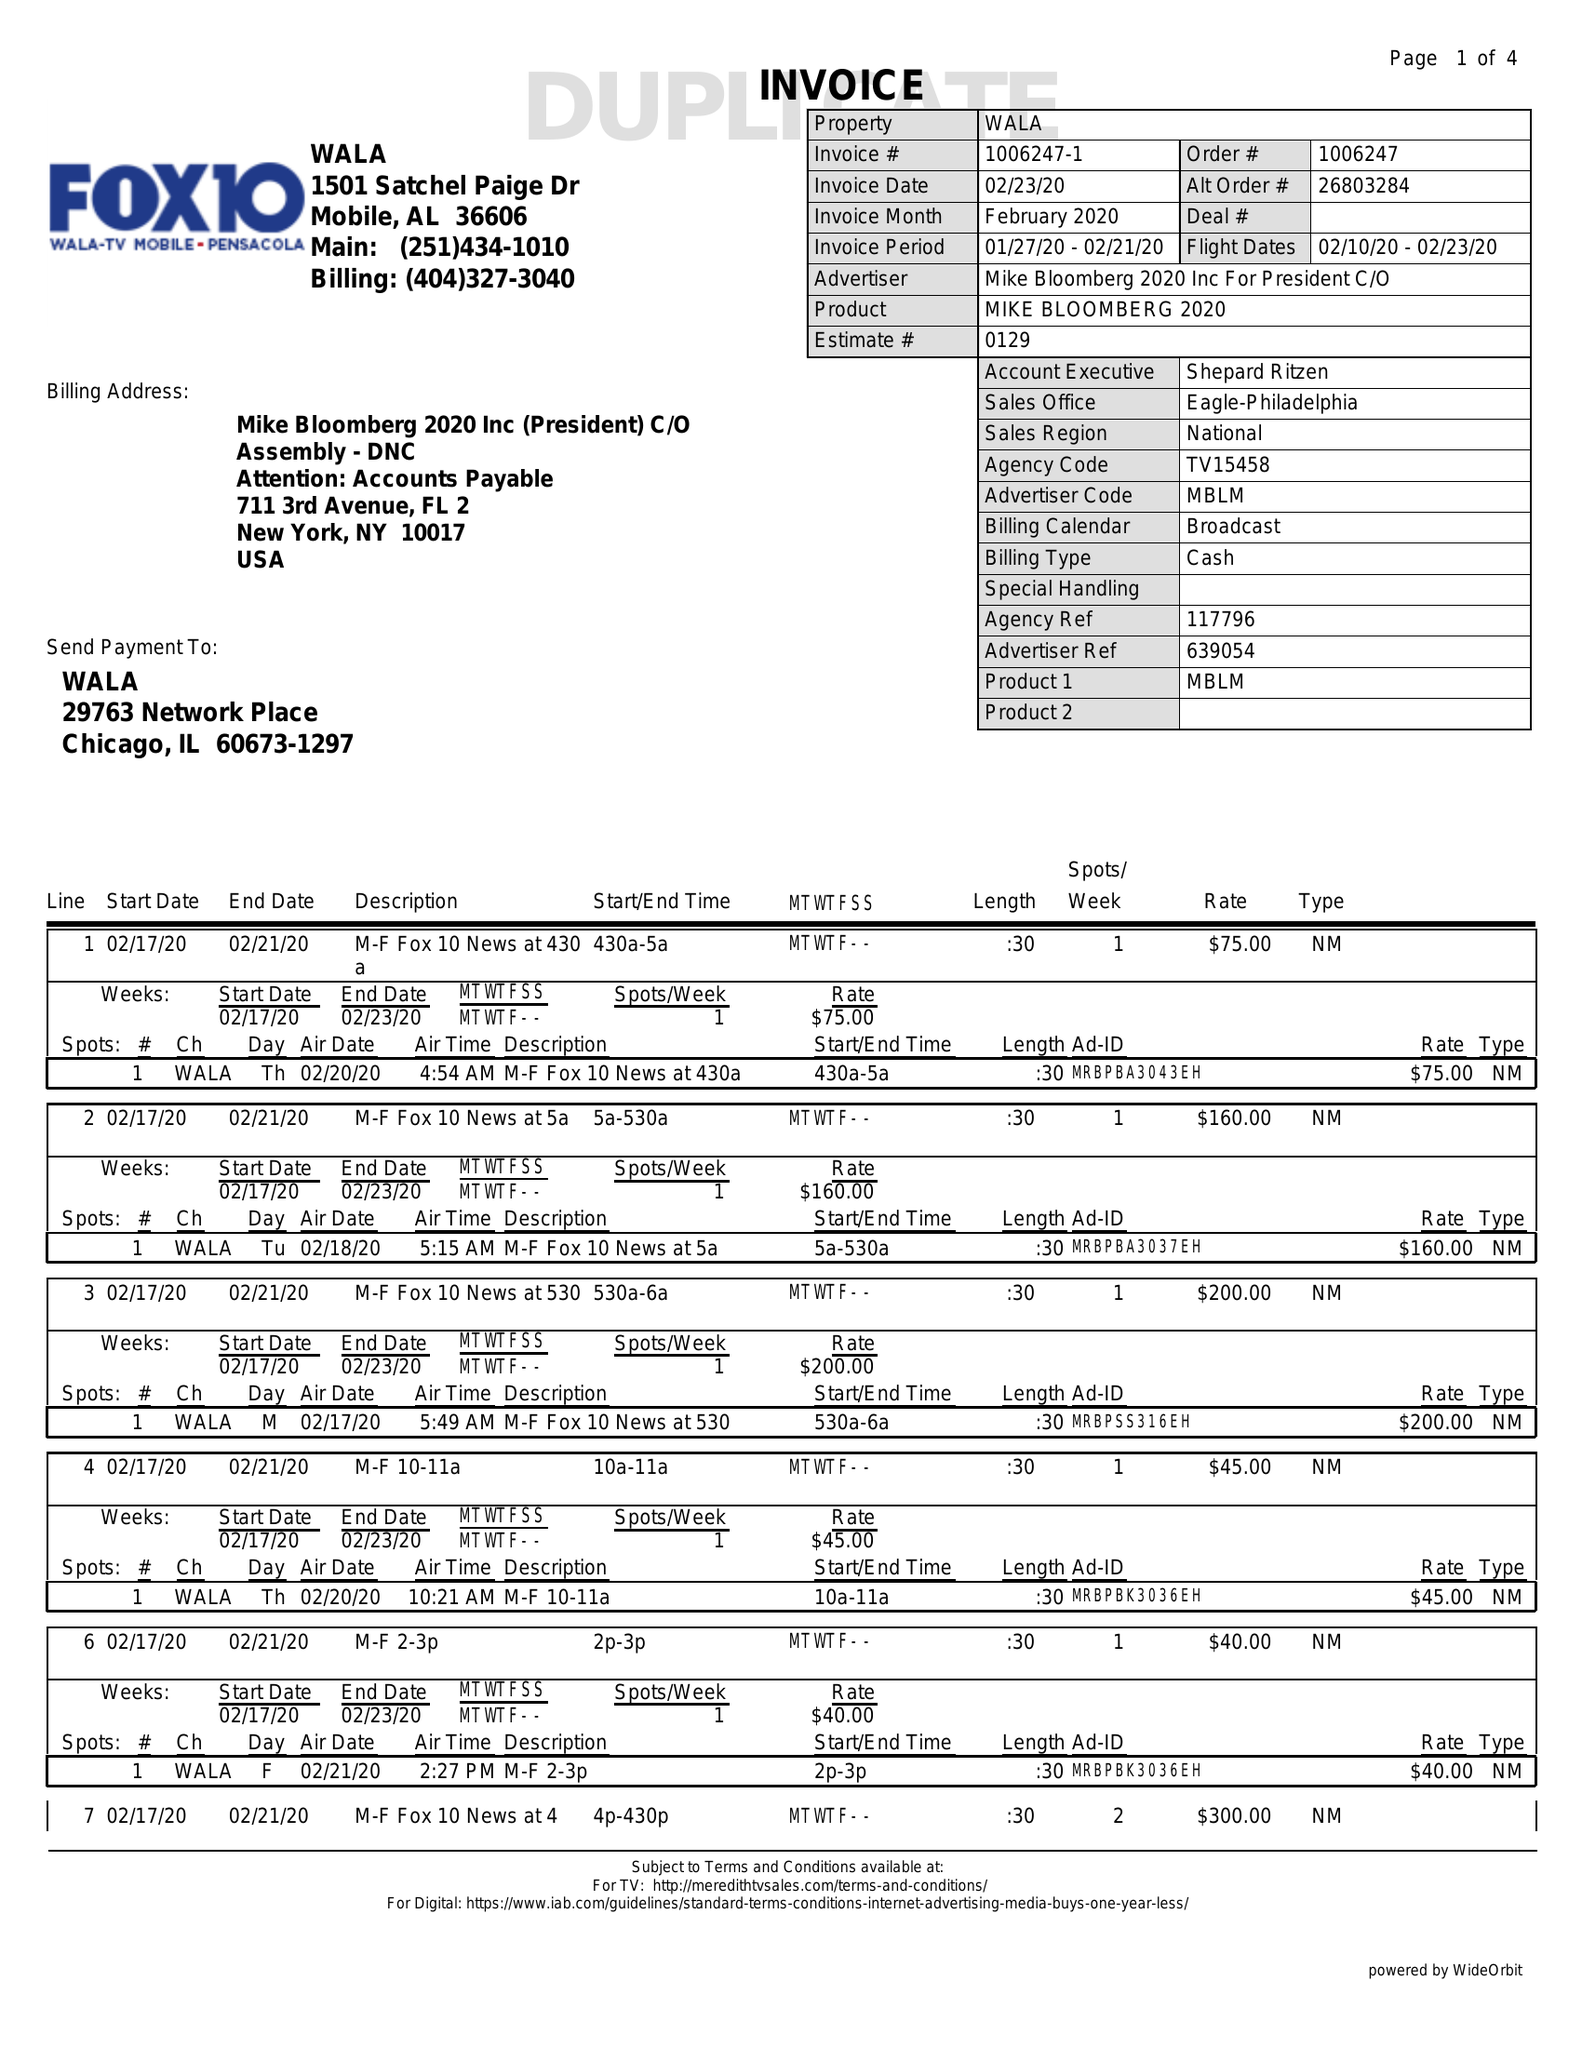What is the value for the flight_to?
Answer the question using a single word or phrase. 02/23/20 